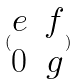Convert formula to latex. <formula><loc_0><loc_0><loc_500><loc_500>( \begin{matrix} e & f \\ 0 & g \end{matrix} )</formula> 